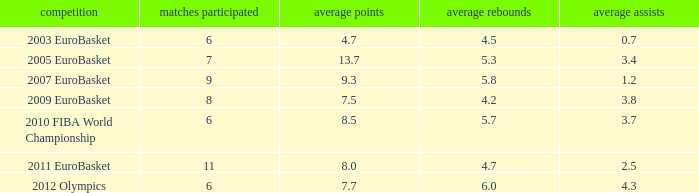How may assists per game have 7.7 points per game? 4.3. 